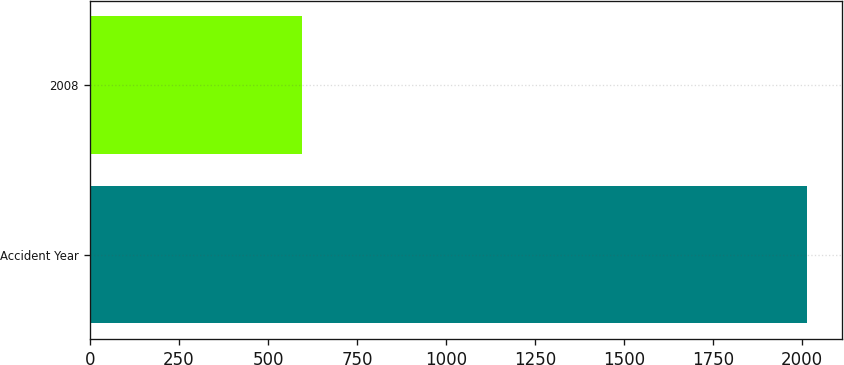Convert chart to OTSL. <chart><loc_0><loc_0><loc_500><loc_500><bar_chart><fcel>Accident Year<fcel>2008<nl><fcel>2012<fcel>595<nl></chart> 